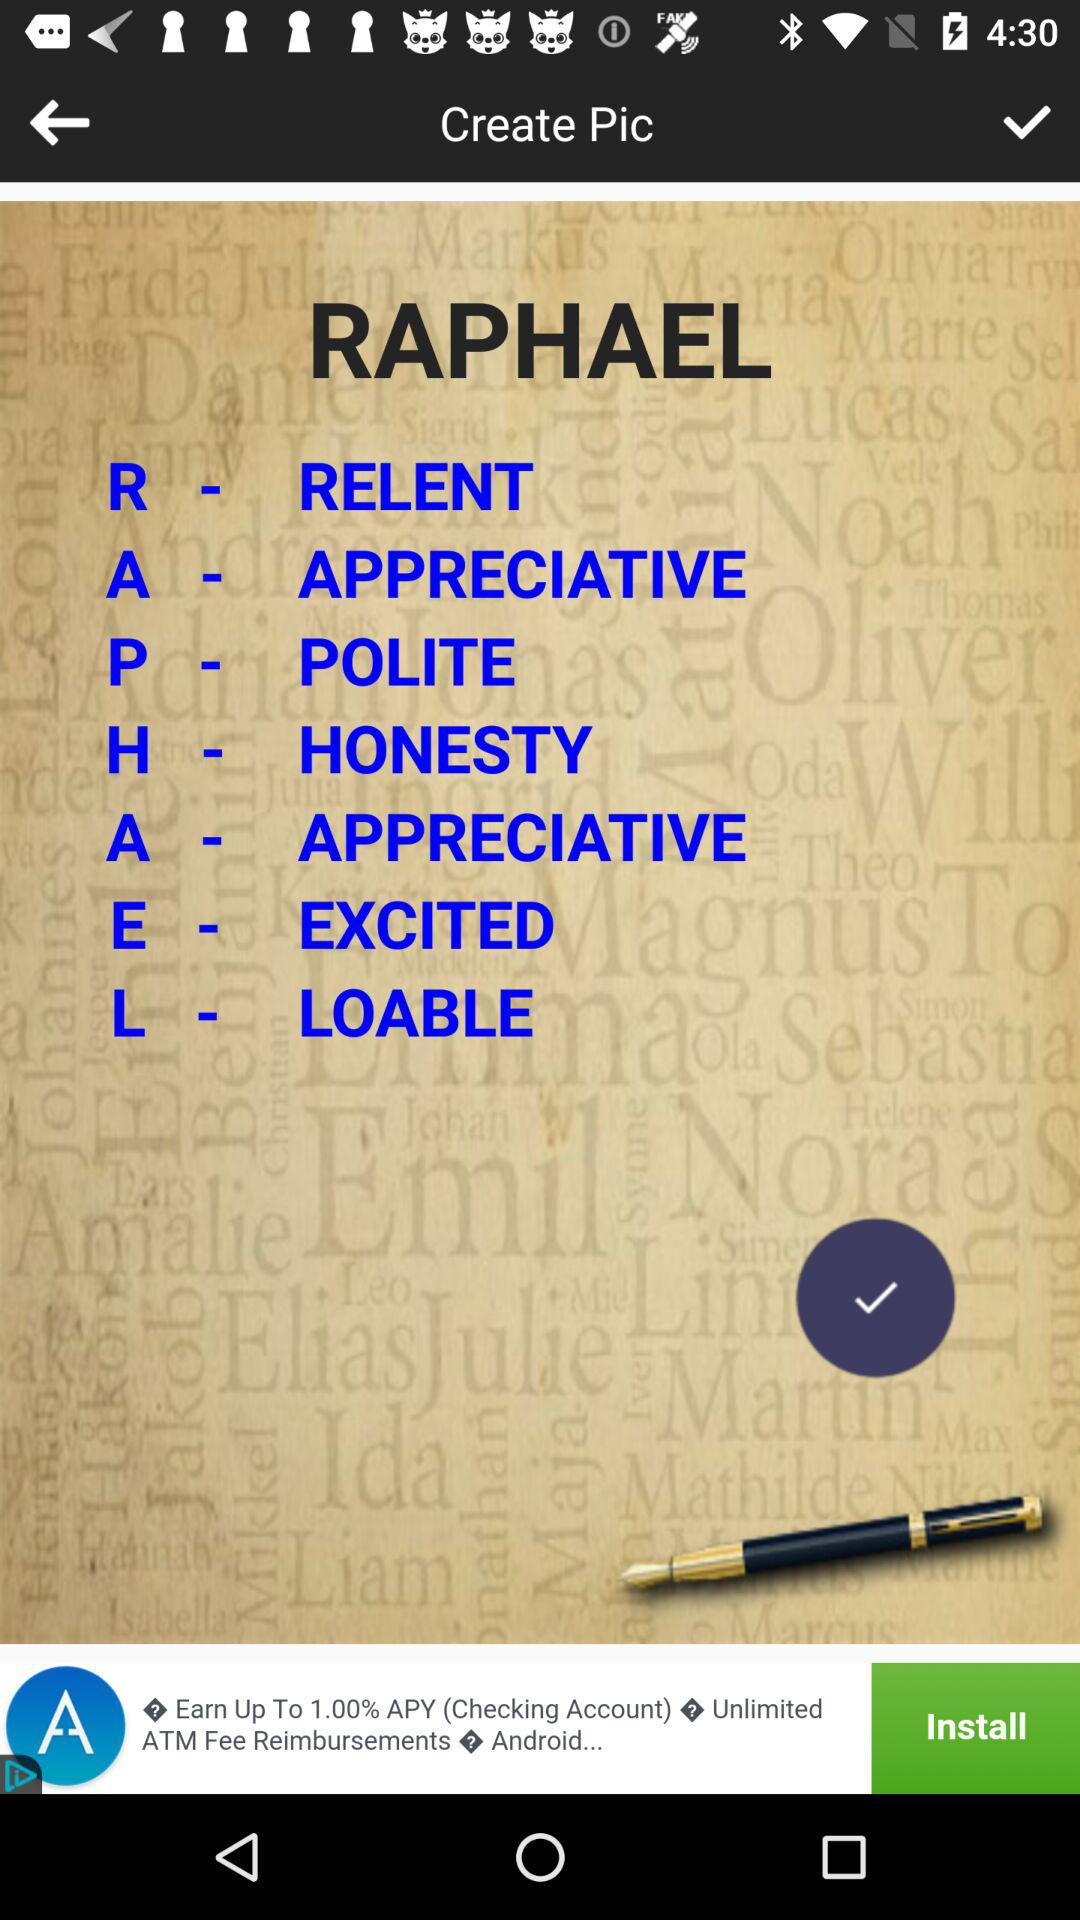What does the letter R stand for? The letter R stand for relent. 